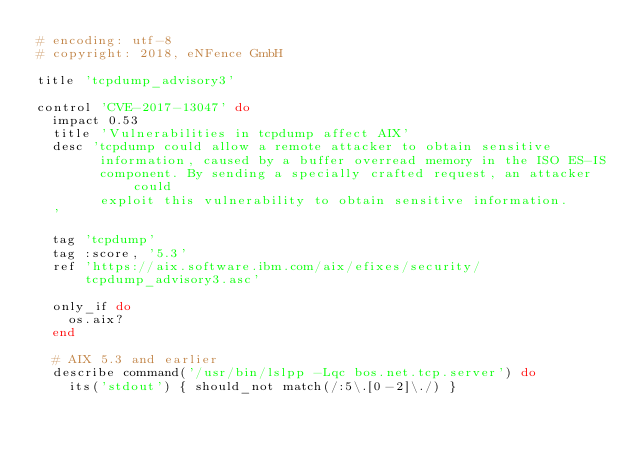Convert code to text. <code><loc_0><loc_0><loc_500><loc_500><_Ruby_># encoding: utf-8
# copyright: 2018, eNFence GmbH

title 'tcpdump_advisory3'

control 'CVE-2017-13047' do
  impact 0.53
  title 'Vulnerabilities in tcpdump affect AIX'
  desc 'tcpdump could allow a remote attacker to obtain sensitive
        information, caused by a buffer overread memory in the ISO ES-IS
        component. By sending a specially crafted request, an attacker could
        exploit this vulnerability to obtain sensitive information.
  '

  tag 'tcpdump'
  tag :score, '5.3'
  ref 'https://aix.software.ibm.com/aix/efixes/security/tcpdump_advisory3.asc'

  only_if do
    os.aix?
  end

  # AIX 5.3 and earlier
  describe command('/usr/bin/lslpp -Lqc bos.net.tcp.server') do
    its('stdout') { should_not match(/:5\.[0-2]\./) }</code> 